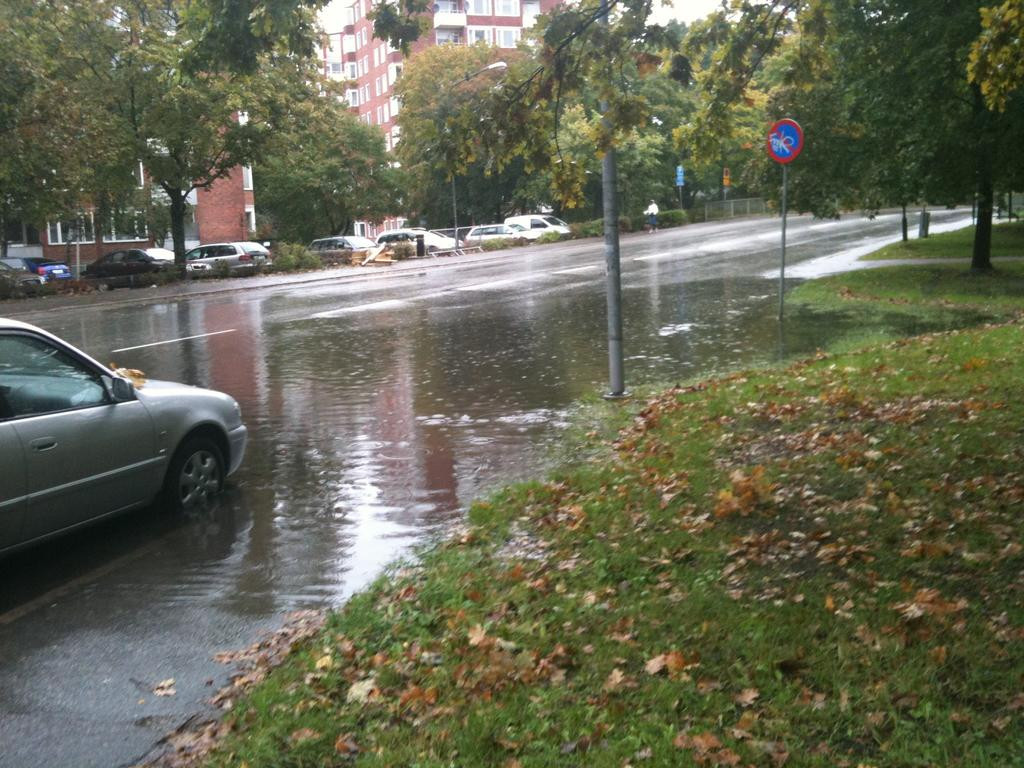What type of vegetation can be seen in the image? There is grass and leaves in the image. What structures are present in the image? There are poles, a road, boards, trees, and buildings in the image. Who or what is present in the image? There is a person and vehicles in the image. What type of rod can be seen in the hands of the police officer in the image? There is no police officer or rod present in the image. How many sticks are being used by the person in the image? There is no person using sticks in the image. 